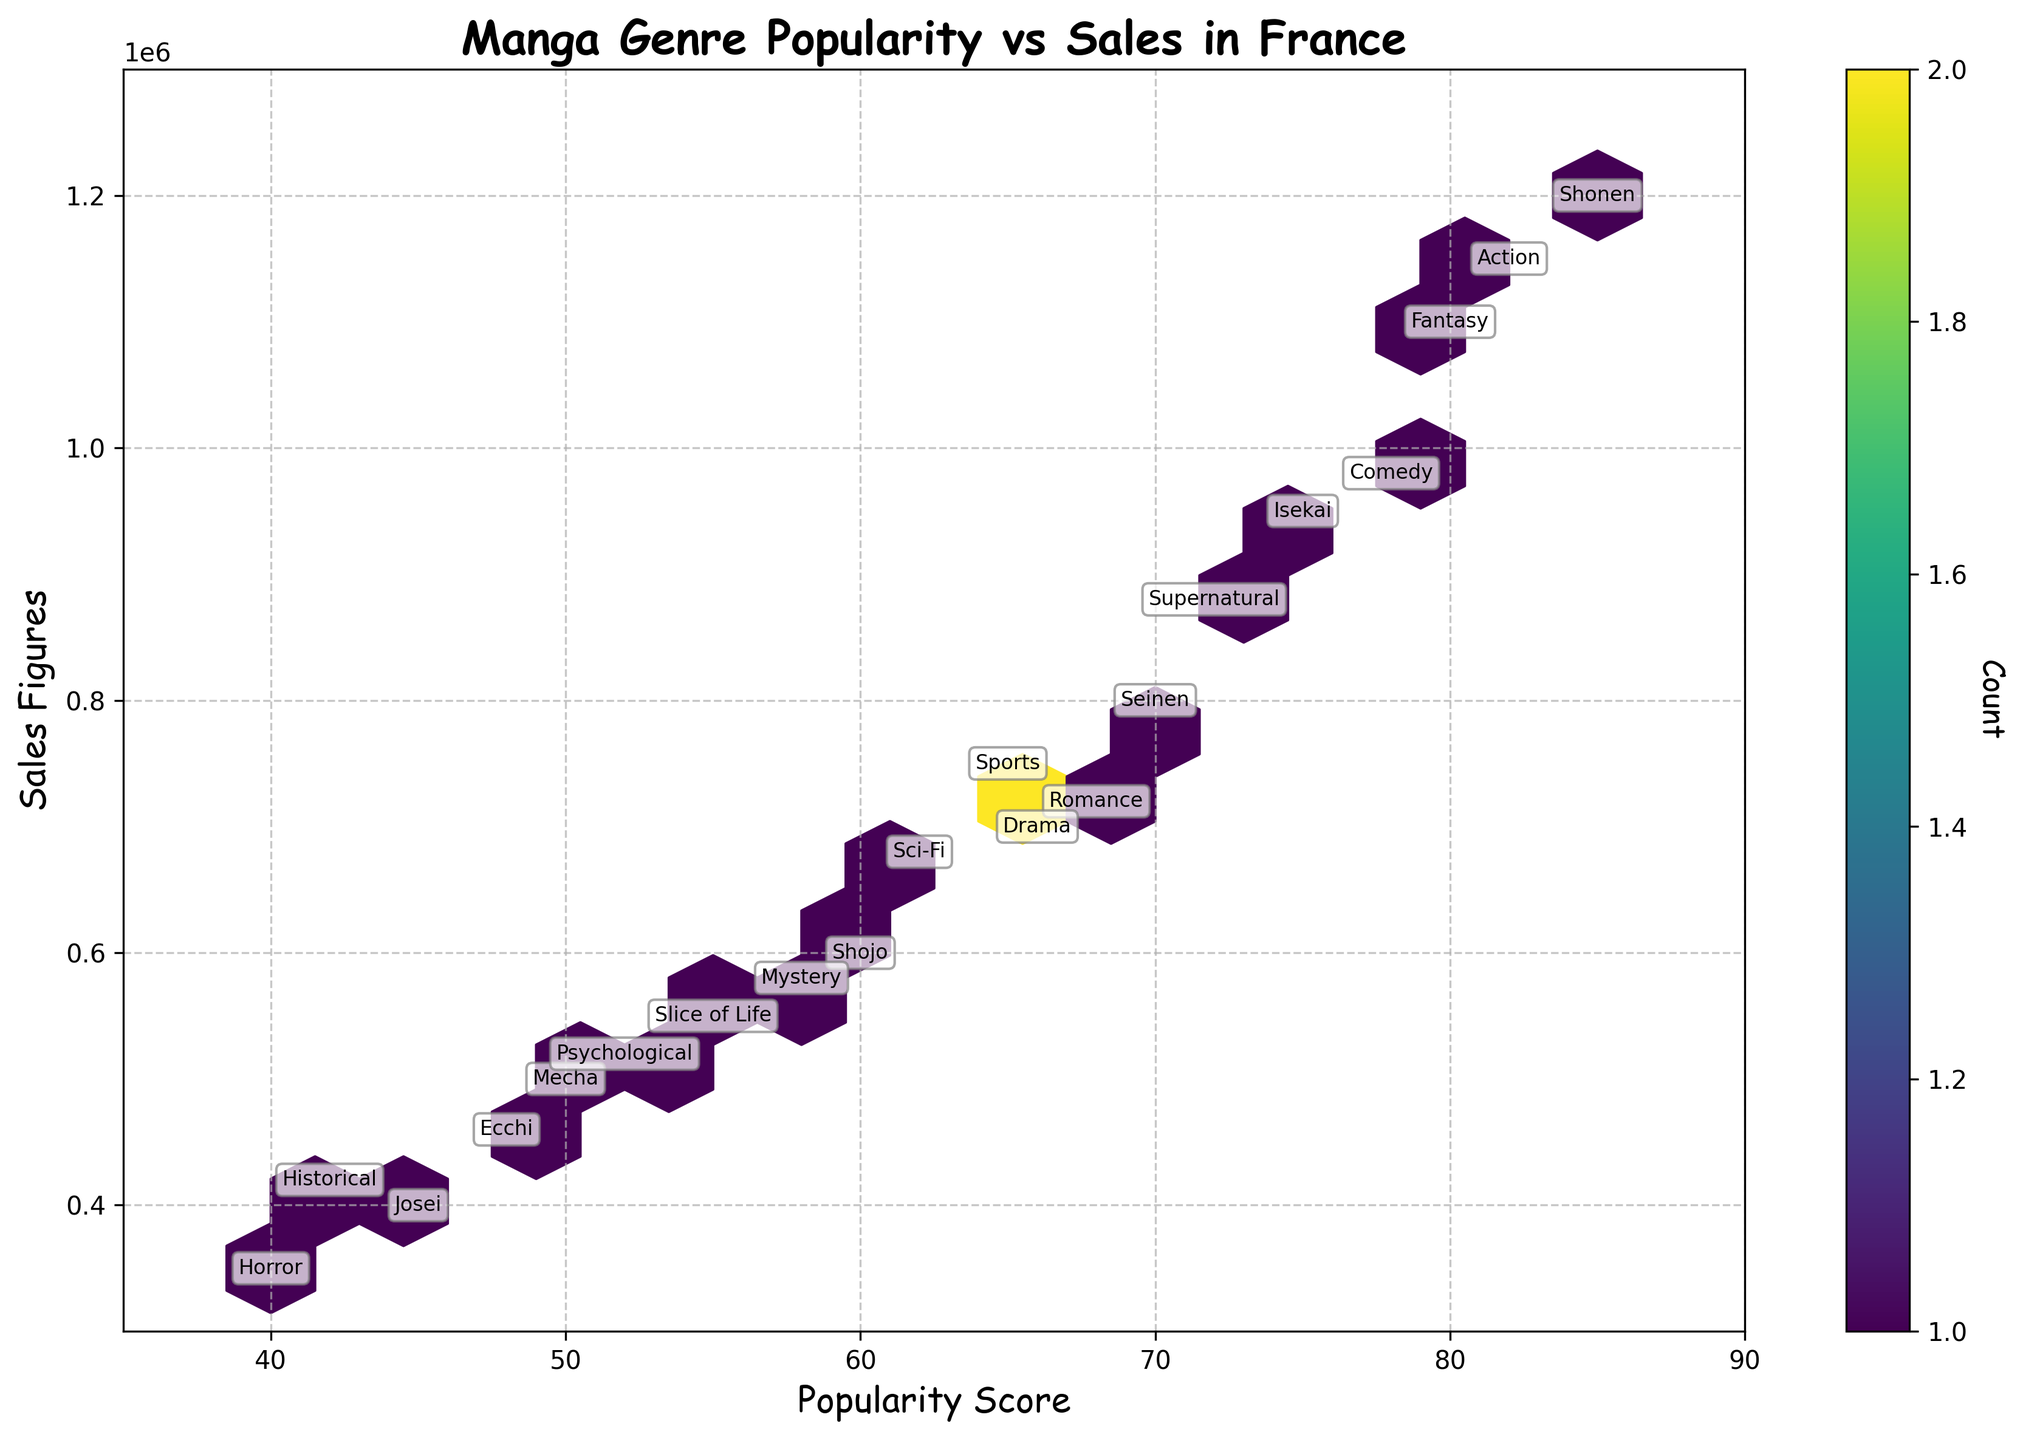What is the most popular manga genre according to the plot? The plot shows the popularity scores of different manga genres. The highest popularity score point on the x-axis belongs to the genre "Shonen" with a score of 85.
Answer: Shonen Which manga genre has the highest sales figures? The plot displays the sales figures on the y-axis. The genre with the highest y-value is "Shonen" with sales figures of 1,200,000.
Answer: Shonen How many manga genres have a popularity score greater than 75? The x-axis represents the popularity score. Counting the genres with a popularity score greater than 75, we find "Shonen", "Isekai", "Comedy", "Fantasy", and "Action".
Answer: 5 Compare the sales figures of the "Seinen" and "Shojo" genres. Which one is higher? "Seinen" has sales figures of 800,000 and "Shojo" has 600,000. Comparing these values, "Seinen" has higher sales figures.
Answer: Seinen What is the overall trend between popularity scores and sales figures? By observing the hexbin plot, we notice that hexagons cluster around a line going upwards from left to right, indicating a positive correlation between popularity scores and sales figures. As the popularity score increases, sales figures also tend to increase.
Answer: Positive correlation Which two genres are closest in both popularity score and sales figures? The plot annotations allow us to identify "Mystery" and "Sci-Fi" as having close proximity in both axes. "Mystery" has a popularity score of 58 and sales figures of 580,000, while "Sci-Fi" has a popularity score of 62 and sales figures of 680,000.
Answer: Mystery and Sci-Fi What is the difference in popularity scores between "Fantasy" and "Ecchi"? The popularity score of "Fantasy" is 80, and for "Ecchi", it is 48. The difference is 80 - 48 = 32.
Answer: 32 Identify the genre that has sales figures of around 700,000 with a mid-range popularity score. From the plot, "Romance" has sales figures of 720,000 and "Drama" has 700,000, both with mid-range popularity scores around 66-68.
Answer: Romance and Drama Where does "Mecha" fall in the plot in terms of popularity and sales? "Mecha" has a popularity score of 50 and sales figures of 500,000, placing it toward the lower-middle range of both axes.
Answer: Lower-middle range What range of values does the colorbar represent on the plot? The colorbar represents the count of data points within each hexagon of the plot. It helps to indicate the density of points. The shades of color range from light to dark as the count increases.
Answer: Count of data points 